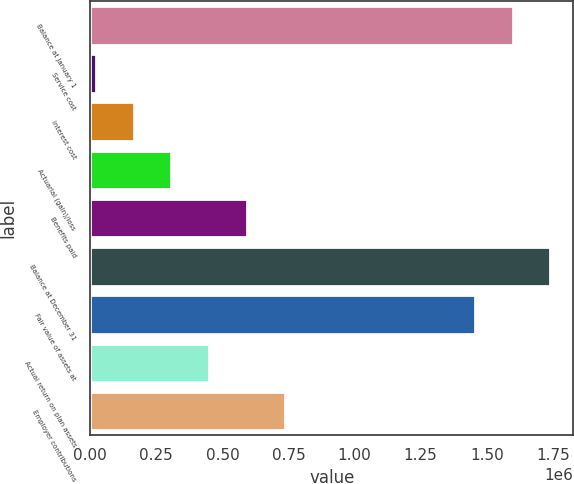Convert chart. <chart><loc_0><loc_0><loc_500><loc_500><bar_chart><fcel>Balance at January 1<fcel>Service cost<fcel>Interest cost<fcel>Actuarial (gain)/loss<fcel>Benefits paid<fcel>Balance at December 31<fcel>Fair value of assets at<fcel>Actual return on plan assets<fcel>Employer contributions<nl><fcel>1.59767e+06<fcel>20724<fcel>164083<fcel>307441<fcel>594158<fcel>1.74103e+06<fcel>1.45431e+06<fcel>450800<fcel>737517<nl></chart> 